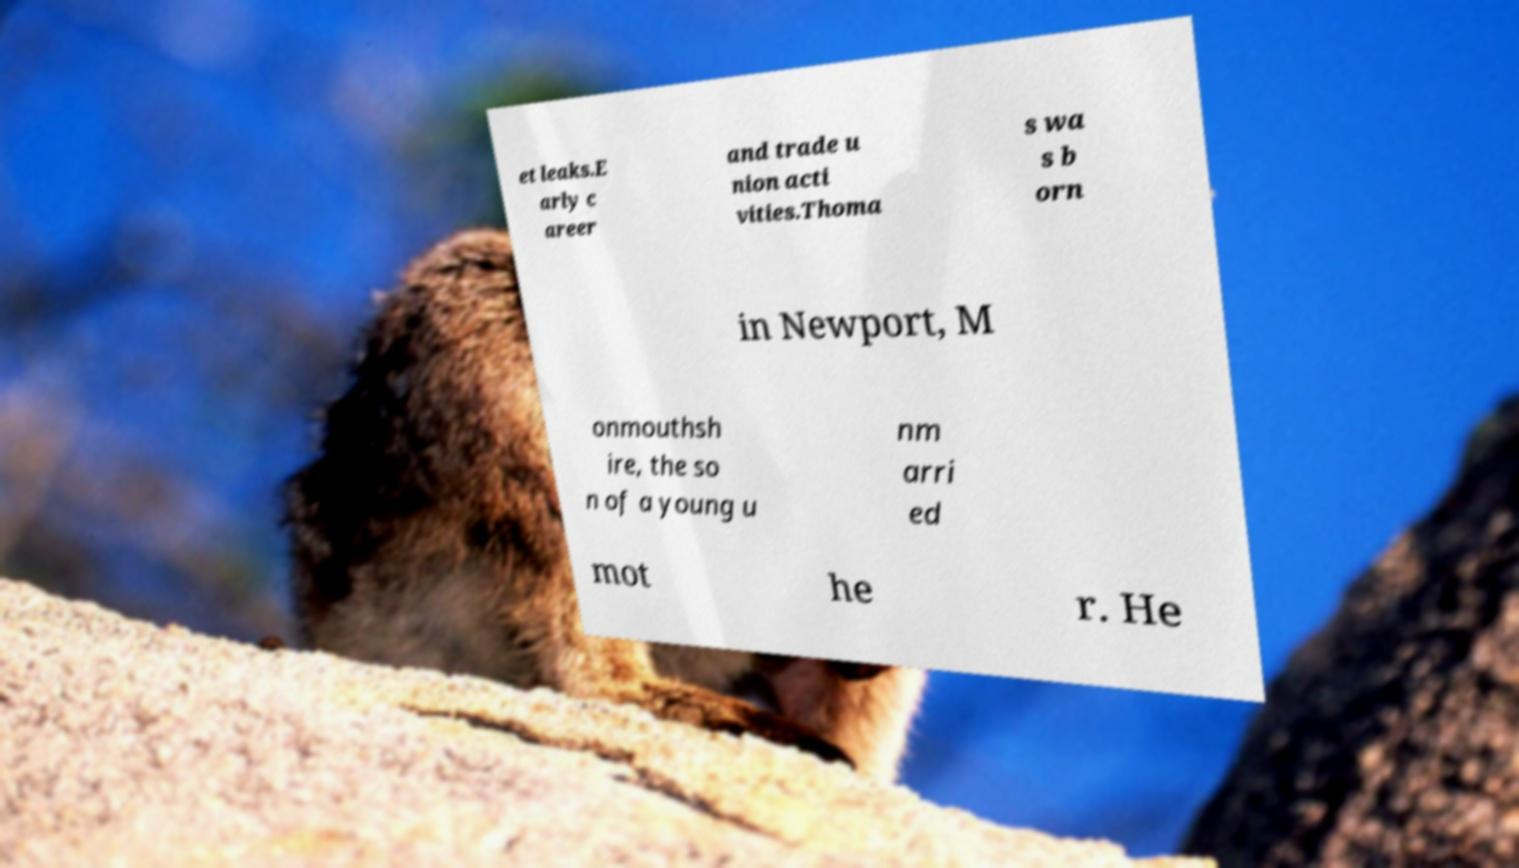For documentation purposes, I need the text within this image transcribed. Could you provide that? et leaks.E arly c areer and trade u nion acti vities.Thoma s wa s b orn in Newport, M onmouthsh ire, the so n of a young u nm arri ed mot he r. He 